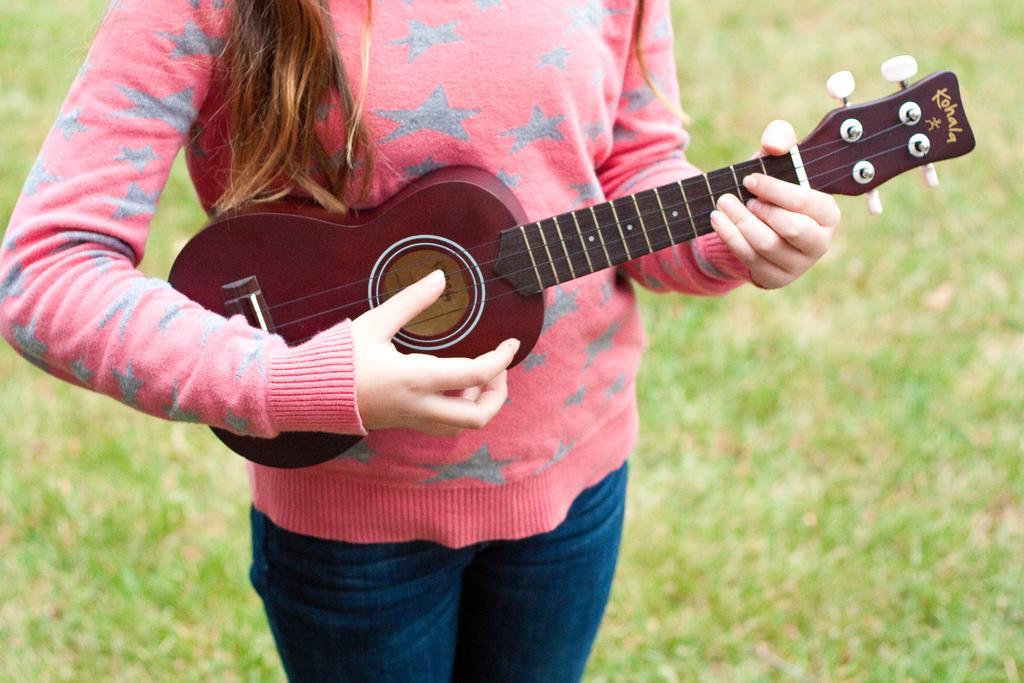Please provide a concise description of this image. In this image i can see a woman wearing pink color dress playing guitar. 